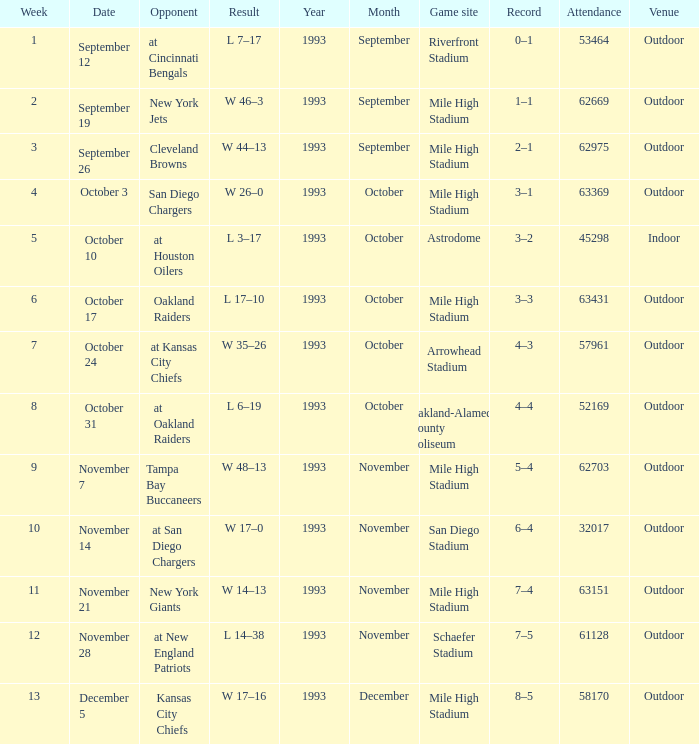What was the week number when the opponent was the New York Jets? 2.0. 